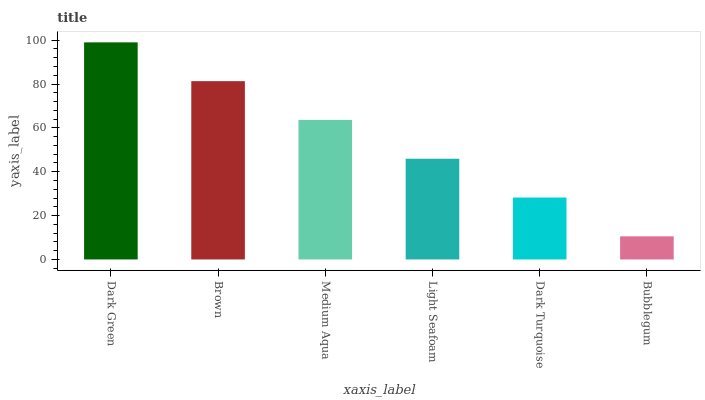Is Bubblegum the minimum?
Answer yes or no. Yes. Is Dark Green the maximum?
Answer yes or no. Yes. Is Brown the minimum?
Answer yes or no. No. Is Brown the maximum?
Answer yes or no. No. Is Dark Green greater than Brown?
Answer yes or no. Yes. Is Brown less than Dark Green?
Answer yes or no. Yes. Is Brown greater than Dark Green?
Answer yes or no. No. Is Dark Green less than Brown?
Answer yes or no. No. Is Medium Aqua the high median?
Answer yes or no. Yes. Is Light Seafoam the low median?
Answer yes or no. Yes. Is Light Seafoam the high median?
Answer yes or no. No. Is Dark Green the low median?
Answer yes or no. No. 